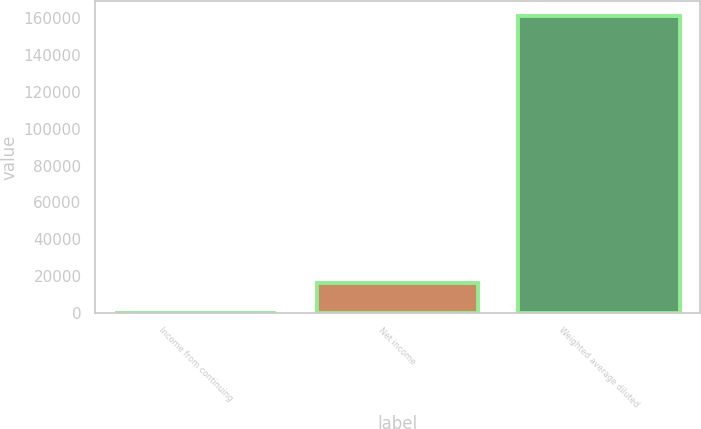Convert chart. <chart><loc_0><loc_0><loc_500><loc_500><bar_chart><fcel>Income from continuing<fcel>Net income<fcel>Weighted average diluted<nl><fcel>0.89<fcel>16152.8<fcel>161520<nl></chart> 